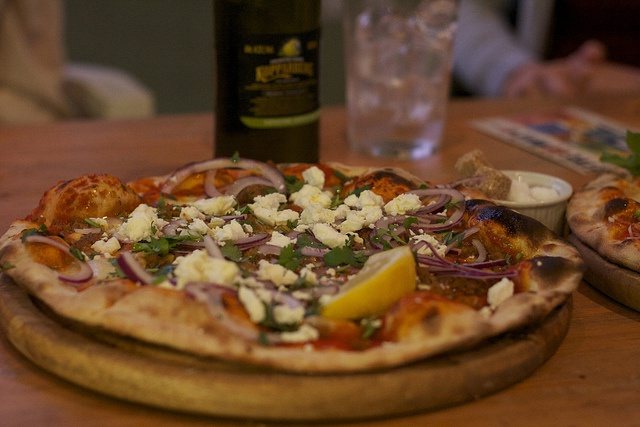Describe the objects in this image and their specific colors. I can see pizza in maroon, brown, tan, and gray tones, dining table in maroon, brown, and black tones, bottle in maroon, black, olive, and gray tones, cup in maroon, brown, and gray tones, and people in maroon and gray tones in this image. 